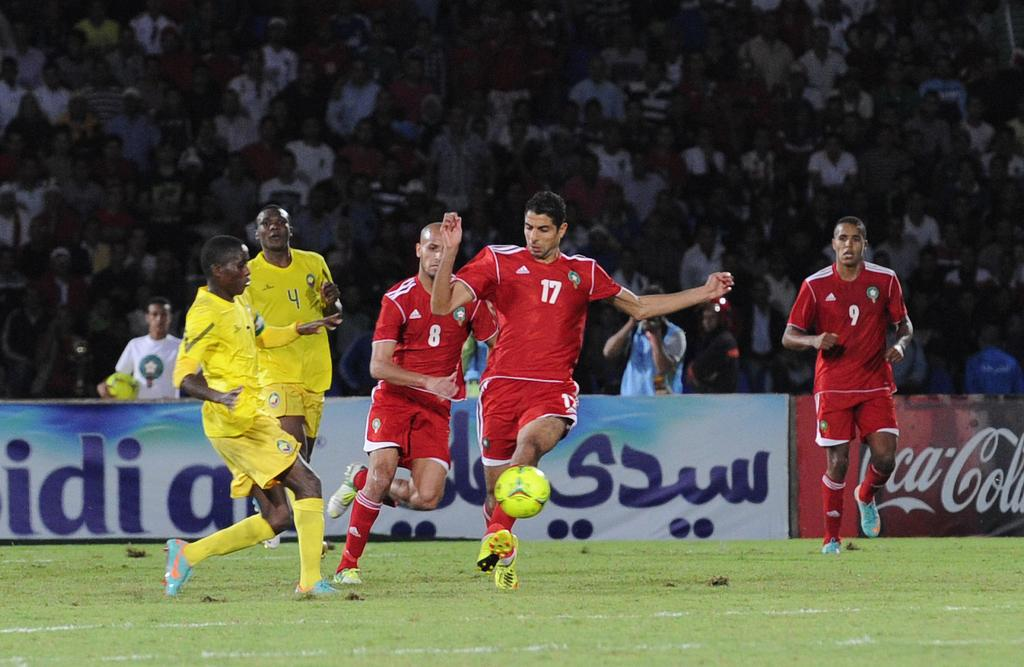<image>
Relay a brief, clear account of the picture shown. a person with the number 17 playing soccer 